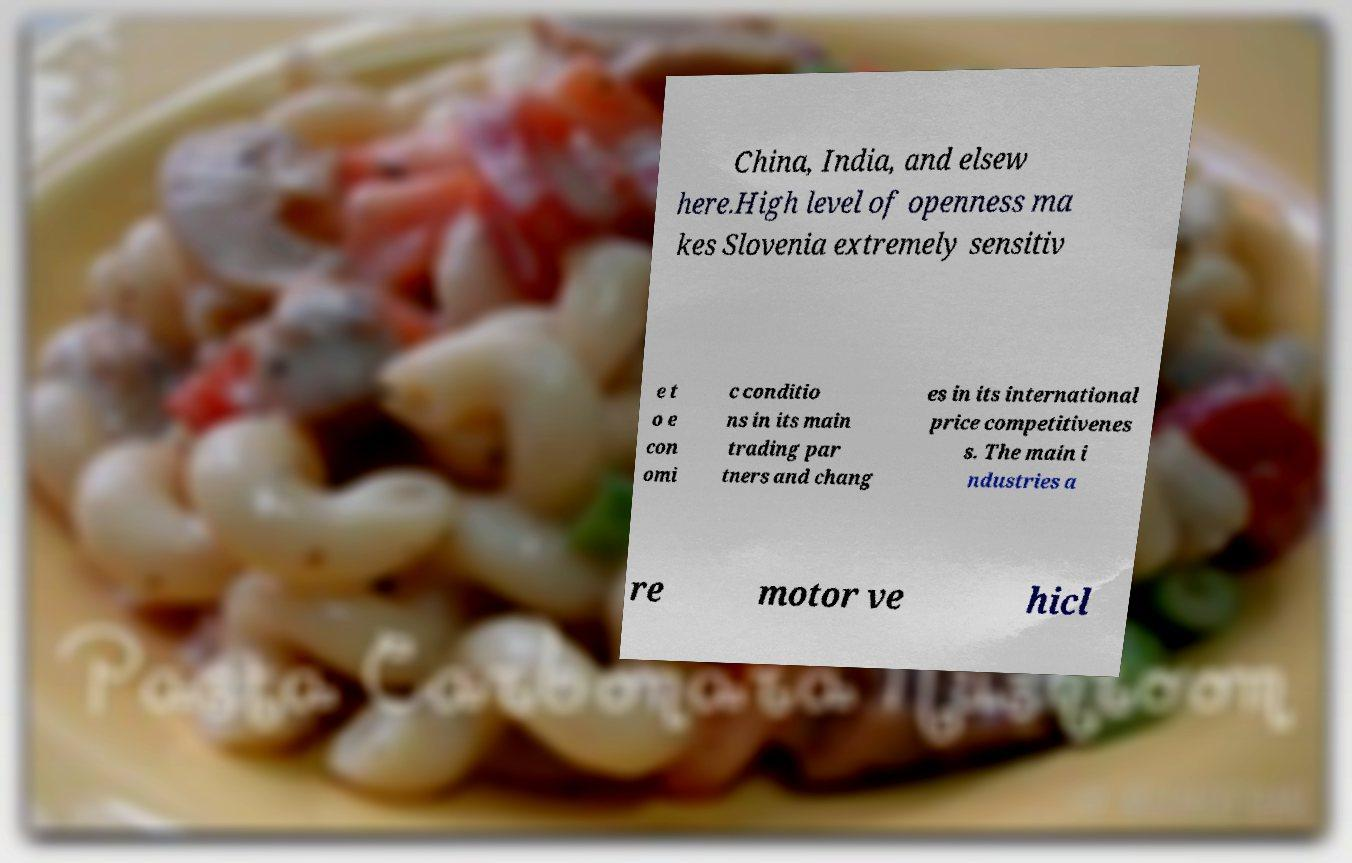I need the written content from this picture converted into text. Can you do that? China, India, and elsew here.High level of openness ma kes Slovenia extremely sensitiv e t o e con omi c conditio ns in its main trading par tners and chang es in its international price competitivenes s. The main i ndustries a re motor ve hicl 